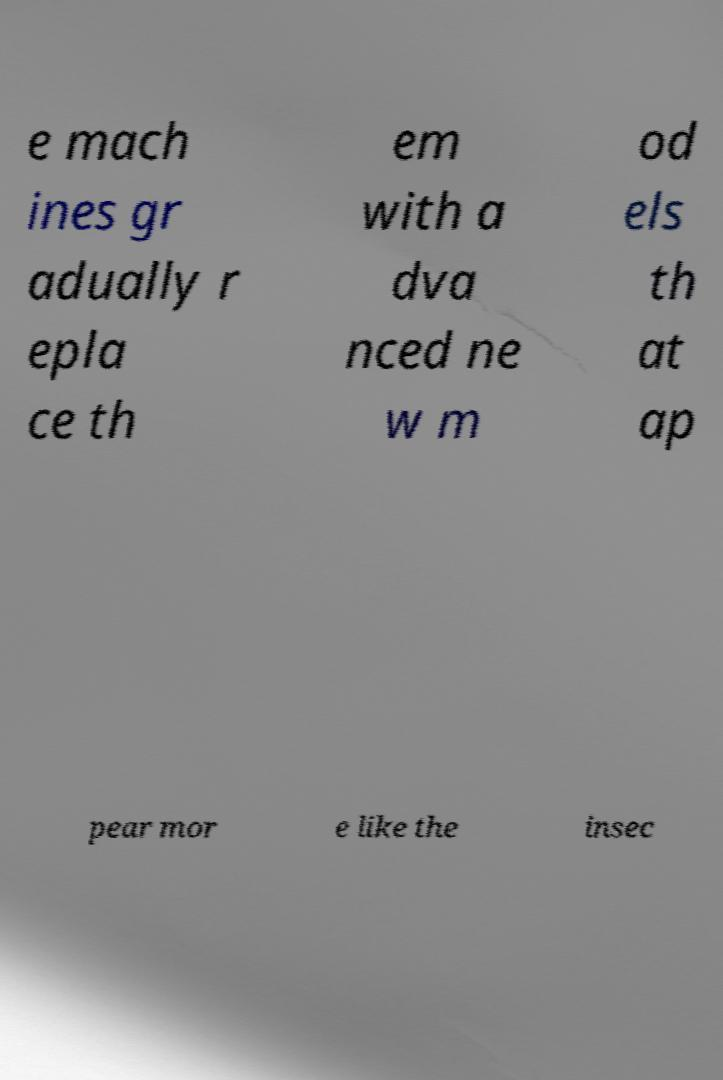I need the written content from this picture converted into text. Can you do that? e mach ines gr adually r epla ce th em with a dva nced ne w m od els th at ap pear mor e like the insec 